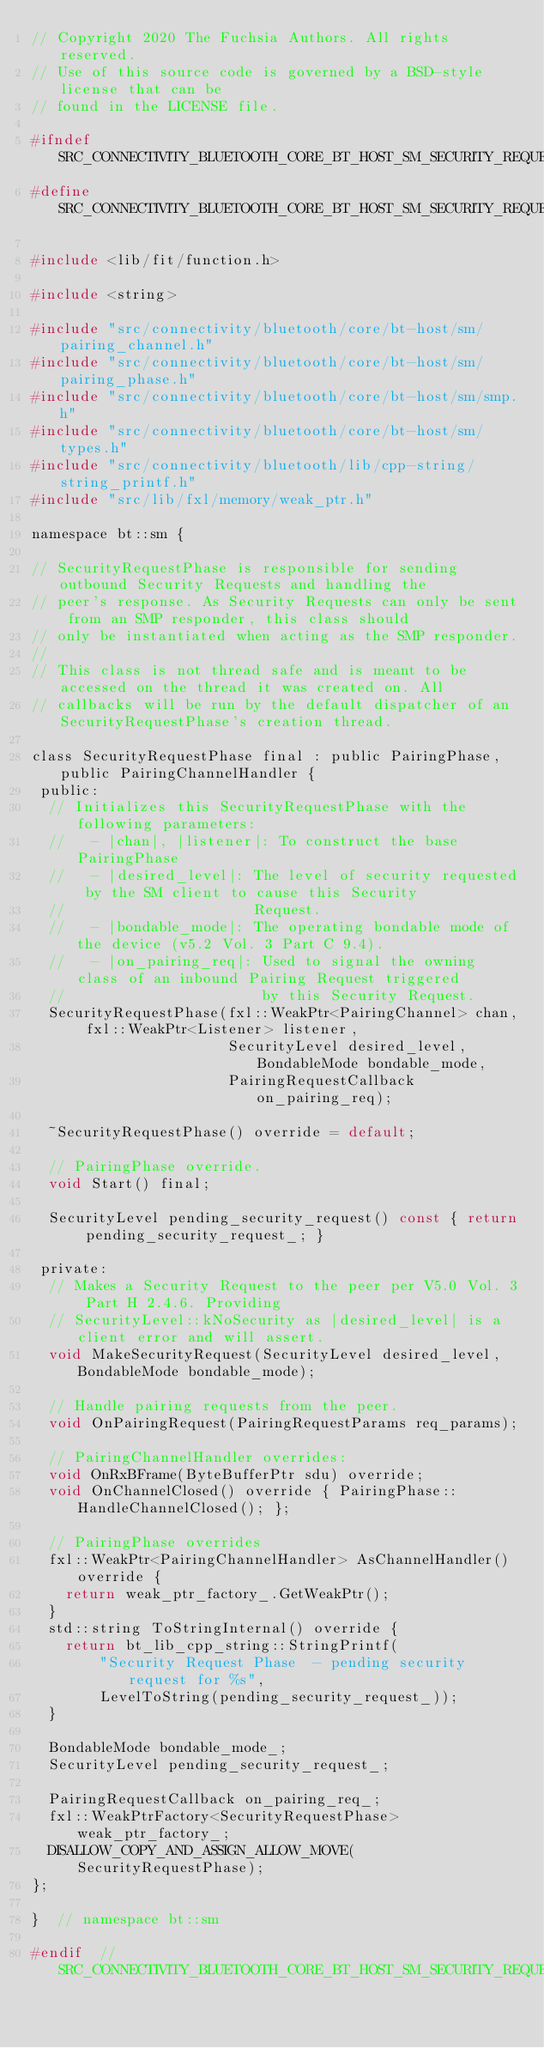<code> <loc_0><loc_0><loc_500><loc_500><_C_>// Copyright 2020 The Fuchsia Authors. All rights reserved.
// Use of this source code is governed by a BSD-style license that can be
// found in the LICENSE file.

#ifndef SRC_CONNECTIVITY_BLUETOOTH_CORE_BT_HOST_SM_SECURITY_REQUEST_PHASE_H_
#define SRC_CONNECTIVITY_BLUETOOTH_CORE_BT_HOST_SM_SECURITY_REQUEST_PHASE_H_

#include <lib/fit/function.h>

#include <string>

#include "src/connectivity/bluetooth/core/bt-host/sm/pairing_channel.h"
#include "src/connectivity/bluetooth/core/bt-host/sm/pairing_phase.h"
#include "src/connectivity/bluetooth/core/bt-host/sm/smp.h"
#include "src/connectivity/bluetooth/core/bt-host/sm/types.h"
#include "src/connectivity/bluetooth/lib/cpp-string/string_printf.h"
#include "src/lib/fxl/memory/weak_ptr.h"

namespace bt::sm {

// SecurityRequestPhase is responsible for sending outbound Security Requests and handling the
// peer's response. As Security Requests can only be sent from an SMP responder, this class should
// only be instantiated when acting as the SMP responder.
//
// This class is not thread safe and is meant to be accessed on the thread it was created on. All
// callbacks will be run by the default dispatcher of an SecurityRequestPhase's creation thread.

class SecurityRequestPhase final : public PairingPhase, public PairingChannelHandler {
 public:
  // Initializes this SecurityRequestPhase with the following parameters:
  //   - |chan|, |listener|: To construct the base PairingPhase
  //   - |desired_level|: The level of security requested by the SM client to cause this Security
  //                      Request.
  //   - |bondable_mode|: The operating bondable mode of the device (v5.2 Vol. 3 Part C 9.4).
  //   - |on_pairing_req|: Used to signal the owning class of an inbound Pairing Request triggered
  //                       by this Security Request.
  SecurityRequestPhase(fxl::WeakPtr<PairingChannel> chan, fxl::WeakPtr<Listener> listener,
                       SecurityLevel desired_level, BondableMode bondable_mode,
                       PairingRequestCallback on_pairing_req);

  ~SecurityRequestPhase() override = default;

  // PairingPhase override.
  void Start() final;

  SecurityLevel pending_security_request() const { return pending_security_request_; }

 private:
  // Makes a Security Request to the peer per V5.0 Vol. 3 Part H 2.4.6. Providing
  // SecurityLevel::kNoSecurity as |desired_level| is a client error and will assert.
  void MakeSecurityRequest(SecurityLevel desired_level, BondableMode bondable_mode);

  // Handle pairing requests from the peer.
  void OnPairingRequest(PairingRequestParams req_params);

  // PairingChannelHandler overrides:
  void OnRxBFrame(ByteBufferPtr sdu) override;
  void OnChannelClosed() override { PairingPhase::HandleChannelClosed(); };

  // PairingPhase overrides
  fxl::WeakPtr<PairingChannelHandler> AsChannelHandler() override {
    return weak_ptr_factory_.GetWeakPtr();
  }
  std::string ToStringInternal() override {
    return bt_lib_cpp_string::StringPrintf(
        "Security Request Phase  - pending security request for %s",
        LevelToString(pending_security_request_));
  }

  BondableMode bondable_mode_;
  SecurityLevel pending_security_request_;

  PairingRequestCallback on_pairing_req_;
  fxl::WeakPtrFactory<SecurityRequestPhase> weak_ptr_factory_;
  DISALLOW_COPY_AND_ASSIGN_ALLOW_MOVE(SecurityRequestPhase);
};

}  // namespace bt::sm

#endif  // SRC_CONNECTIVITY_BLUETOOTH_CORE_BT_HOST_SM_SECURITY_REQUEST_PHASE_H_
</code> 